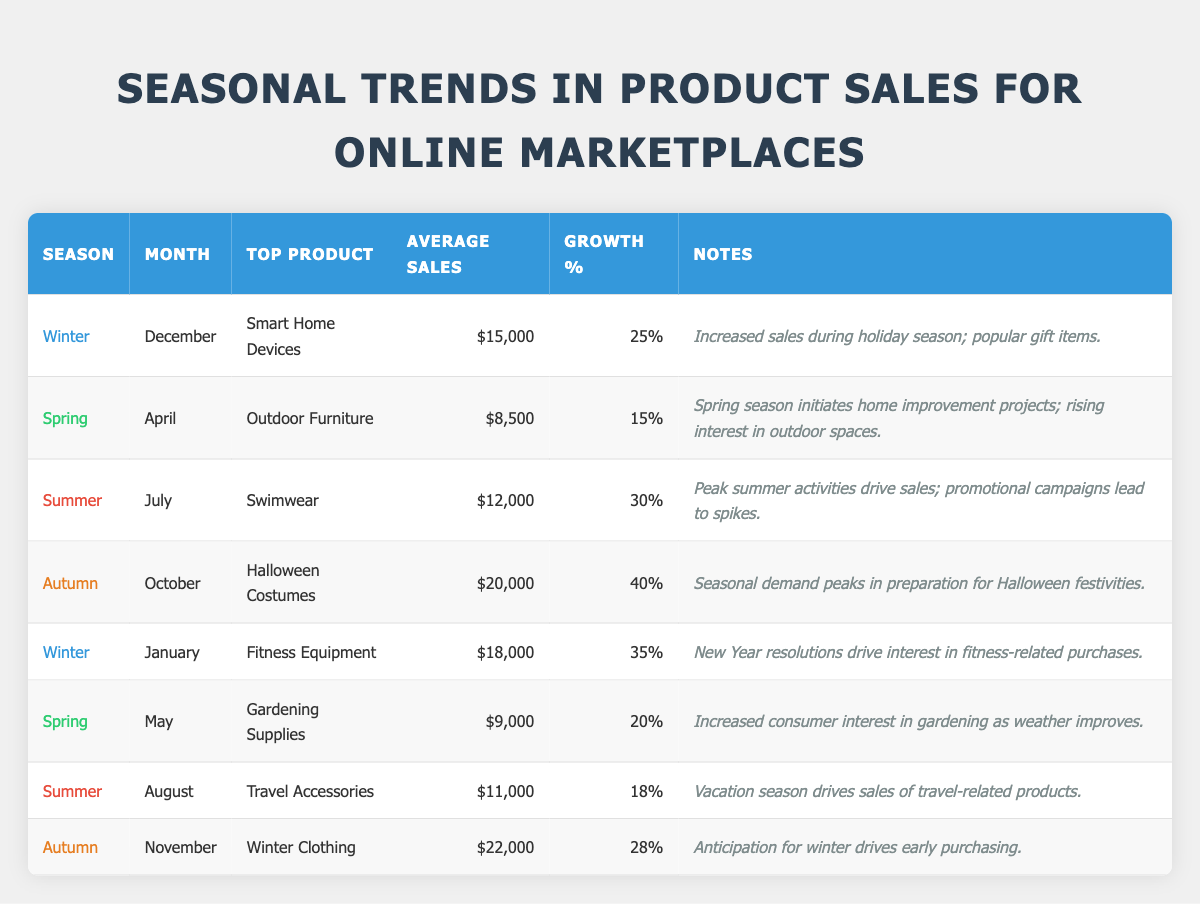What is the top product sold in the Autumn season? By looking at the table, in the Autumn season, there are two entries: October has "Halloween Costumes" and November has "Winter Clothing." The average sales for Winter Clothing in November is higher at $22,000 compared to $20,000 for Halloween Costumes in October. Thus, the top product is "Winter Clothing."
Answer: Winter Clothing Which month has the highest average sales, and what is that amount? Scanning the table for the highest average sales reveals November with Winter Clothing at $22,000, which is greater than all other monthly entries. Therefore, November has the highest average sales.
Answer: $22,000 What is the growth percentage of Swimwear in Summer? Referring directly to the table, the July entry under Summer indicates a growth percentage of 30% for Swimwear.
Answer: 30% Is there an increase in average sales from Spring to Summer? Looking at the Spring months, April has average sales of $8,500 (Outdoor Furniture) and May has $9,000 (Gardening Supplies), giving a total of $17,500 for Spring. In Summer, July has $12,000 (Swimwear) and August has $11,000 (Travel Accessories), for a total of $23,000. Since $23,000 (Summer total) is greater than $17,500 (Spring total), there is indeed an increase.
Answer: Yes What is the trend of average sales from Winter to Spring? For Winter, the average sales are $15,000 in December (Smart Home Devices) and $18,000 in January (Fitness Equipment), leading to a total of $33,000 for Winter. In Spring, April shows $8,500 (Outdoor Furniture) and May shows $9,000 (Gardening Supplies), totaling $17,500 for Spring. Since $33,000 (Winter total) is greater than $17,500 (Spring total), thus indicating a decrease in sales.
Answer: Decrease Which product in Winter had the highest average sales? In Winter, December features Smart Home Devices with average sales of $15,000, while January features Fitness Equipment with average sales of $18,000. Comparing these values, Fitness Equipment has the higher average sales.
Answer: Fitness Equipment If we compare the average sales of top products for all seasons, which season's top product generated the highest sales? Reviewing the values: Winter (January: $18,000), Spring (May: $9,000), Summer (July: $12,000), and Autumn (November: $22,000), it is evident that November's Winter Clothing generated the highest sales at $22,000 among all seasons.
Answer: Autumn What is the difference in average sales between Halloween Costumes and Swimwear? The average sales for Halloween Costumes in October is $20,000, while for Swimwear in July, it is $12,000. By calculating the difference: $20,000 - $12,000 = $8,000. Therefore, Halloween Costumes sell $8,000 more than Swimwear.
Answer: $8,000 Which season saw the highest growth percentage, and what is that percentage? In the table, Halloween Costumes in Autumn (October) has the highest growth percentage of 40%. This is higher than all other entries, making it the peak growth percentage identified in the data.
Answer: 40% How much did average sales increase from December to January in Winter? Average sales for December (Smart Home Devices) are $15,000, and for January (Fitness Equipment) are $18,000. Calculating the increase: $18,000 - $15,000 = $3,000. Consequently, there was an increase of $3,000 from December to January.
Answer: $3,000 What average sales amount corresponds to the lower growth percentage in Spring? In Spring, comparing average sales and growth percentages, April (Outdoor Furniture) has $8,500 and 15%, while May (Gardening Supplies) has $9,000 and 20%. Since April has the lower growth percentage, its average sales of $8,500 corresponds to that figure.
Answer: $8,500 